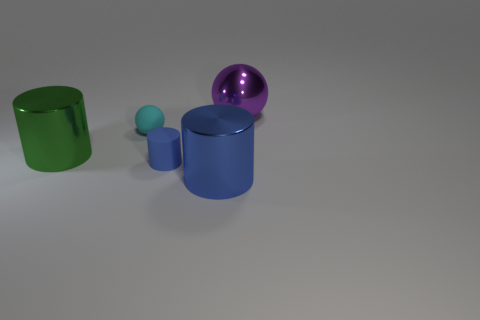Add 2 small rubber objects. How many objects exist? 7 Subtract all large green cylinders. How many cylinders are left? 2 Subtract 2 cylinders. How many cylinders are left? 1 Subtract all cyan balls. How many balls are left? 1 Subtract all green spheres. Subtract all cyan cylinders. How many spheres are left? 2 Subtract all spheres. How many objects are left? 3 Subtract all purple spheres. How many green cylinders are left? 1 Subtract all big cylinders. Subtract all rubber cylinders. How many objects are left? 2 Add 1 tiny things. How many tiny things are left? 3 Add 4 purple shiny things. How many purple shiny things exist? 5 